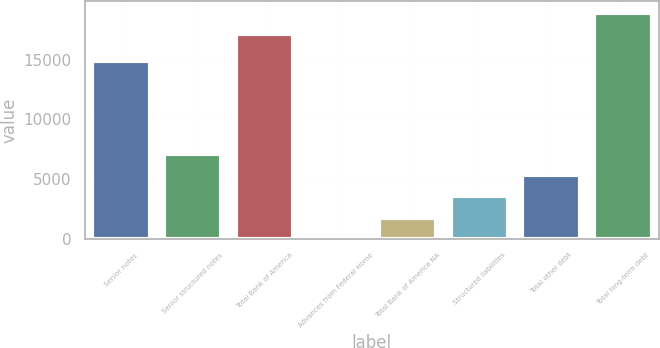Convert chart. <chart><loc_0><loc_0><loc_500><loc_500><bar_chart><fcel>Senior notes<fcel>Senior structured notes<fcel>Total Bank of America<fcel>Advances from Federal Home<fcel>Total Bank of America NA<fcel>Structured liabilities<fcel>Total other debt<fcel>Total long-term debt<nl><fcel>14882<fcel>7091<fcel>17160<fcel>3<fcel>1775<fcel>3547<fcel>5319<fcel>18932<nl></chart> 